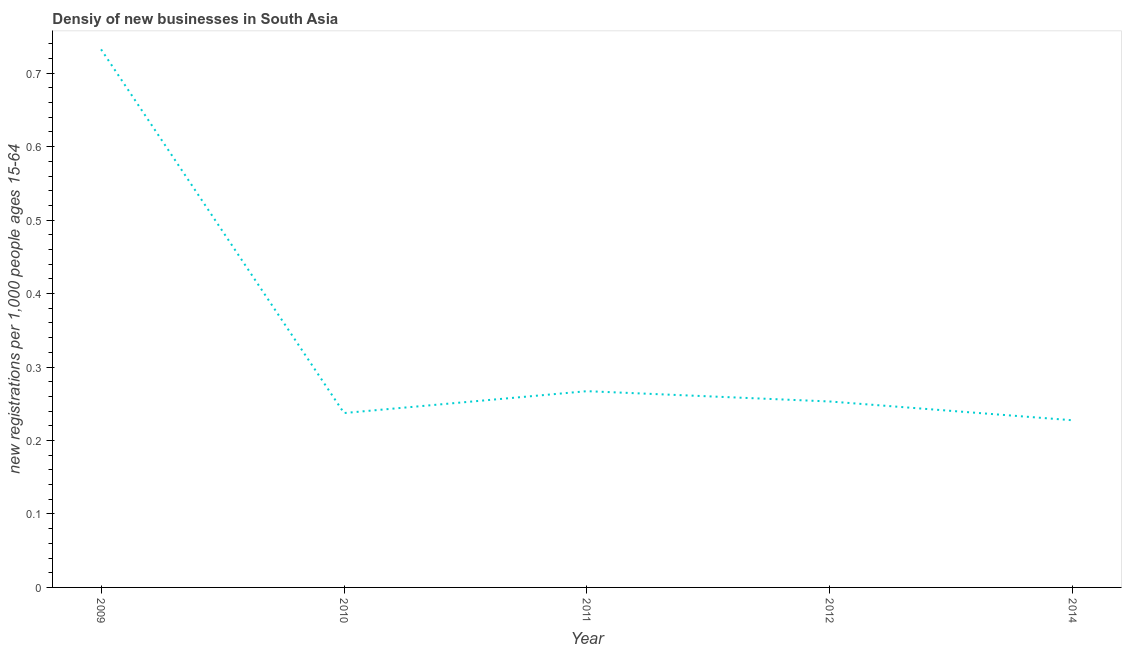What is the density of new business in 2011?
Ensure brevity in your answer.  0.27. Across all years, what is the maximum density of new business?
Provide a succinct answer. 0.73. Across all years, what is the minimum density of new business?
Ensure brevity in your answer.  0.23. In which year was the density of new business maximum?
Your answer should be very brief. 2009. What is the sum of the density of new business?
Offer a terse response. 1.72. What is the difference between the density of new business in 2009 and 2010?
Provide a succinct answer. 0.5. What is the average density of new business per year?
Your answer should be compact. 0.34. What is the median density of new business?
Your answer should be compact. 0.25. What is the ratio of the density of new business in 2009 to that in 2011?
Provide a short and direct response. 2.74. Is the density of new business in 2010 less than that in 2014?
Your answer should be very brief. No. What is the difference between the highest and the second highest density of new business?
Your answer should be compact. 0.47. What is the difference between the highest and the lowest density of new business?
Your response must be concise. 0.5. In how many years, is the density of new business greater than the average density of new business taken over all years?
Give a very brief answer. 1. Does the density of new business monotonically increase over the years?
Your response must be concise. No. How many years are there in the graph?
Your answer should be very brief. 5. Are the values on the major ticks of Y-axis written in scientific E-notation?
Provide a short and direct response. No. Does the graph contain any zero values?
Provide a succinct answer. No. Does the graph contain grids?
Your response must be concise. No. What is the title of the graph?
Provide a succinct answer. Densiy of new businesses in South Asia. What is the label or title of the X-axis?
Offer a terse response. Year. What is the label or title of the Y-axis?
Keep it short and to the point. New registrations per 1,0 people ages 15-64. What is the new registrations per 1,000 people ages 15-64 of 2009?
Ensure brevity in your answer.  0.73. What is the new registrations per 1,000 people ages 15-64 of 2010?
Ensure brevity in your answer.  0.24. What is the new registrations per 1,000 people ages 15-64 of 2011?
Your answer should be compact. 0.27. What is the new registrations per 1,000 people ages 15-64 of 2012?
Ensure brevity in your answer.  0.25. What is the new registrations per 1,000 people ages 15-64 in 2014?
Keep it short and to the point. 0.23. What is the difference between the new registrations per 1,000 people ages 15-64 in 2009 and 2010?
Make the answer very short. 0.5. What is the difference between the new registrations per 1,000 people ages 15-64 in 2009 and 2011?
Make the answer very short. 0.47. What is the difference between the new registrations per 1,000 people ages 15-64 in 2009 and 2012?
Your answer should be compact. 0.48. What is the difference between the new registrations per 1,000 people ages 15-64 in 2009 and 2014?
Your answer should be very brief. 0.5. What is the difference between the new registrations per 1,000 people ages 15-64 in 2010 and 2011?
Your answer should be very brief. -0.03. What is the difference between the new registrations per 1,000 people ages 15-64 in 2010 and 2012?
Offer a very short reply. -0.02. What is the difference between the new registrations per 1,000 people ages 15-64 in 2010 and 2014?
Your answer should be compact. 0.01. What is the difference between the new registrations per 1,000 people ages 15-64 in 2011 and 2012?
Provide a succinct answer. 0.01. What is the difference between the new registrations per 1,000 people ages 15-64 in 2011 and 2014?
Keep it short and to the point. 0.04. What is the difference between the new registrations per 1,000 people ages 15-64 in 2012 and 2014?
Your response must be concise. 0.03. What is the ratio of the new registrations per 1,000 people ages 15-64 in 2009 to that in 2010?
Offer a terse response. 3.08. What is the ratio of the new registrations per 1,000 people ages 15-64 in 2009 to that in 2011?
Provide a short and direct response. 2.74. What is the ratio of the new registrations per 1,000 people ages 15-64 in 2009 to that in 2012?
Offer a very short reply. 2.89. What is the ratio of the new registrations per 1,000 people ages 15-64 in 2009 to that in 2014?
Offer a terse response. 3.22. What is the ratio of the new registrations per 1,000 people ages 15-64 in 2010 to that in 2011?
Keep it short and to the point. 0.89. What is the ratio of the new registrations per 1,000 people ages 15-64 in 2010 to that in 2012?
Offer a terse response. 0.94. What is the ratio of the new registrations per 1,000 people ages 15-64 in 2010 to that in 2014?
Your answer should be very brief. 1.04. What is the ratio of the new registrations per 1,000 people ages 15-64 in 2011 to that in 2012?
Your response must be concise. 1.06. What is the ratio of the new registrations per 1,000 people ages 15-64 in 2011 to that in 2014?
Give a very brief answer. 1.17. What is the ratio of the new registrations per 1,000 people ages 15-64 in 2012 to that in 2014?
Keep it short and to the point. 1.11. 